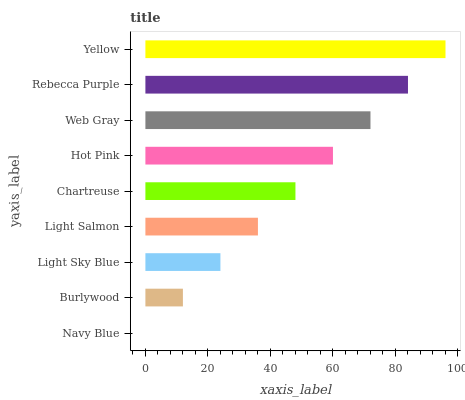Is Navy Blue the minimum?
Answer yes or no. Yes. Is Yellow the maximum?
Answer yes or no. Yes. Is Burlywood the minimum?
Answer yes or no. No. Is Burlywood the maximum?
Answer yes or no. No. Is Burlywood greater than Navy Blue?
Answer yes or no. Yes. Is Navy Blue less than Burlywood?
Answer yes or no. Yes. Is Navy Blue greater than Burlywood?
Answer yes or no. No. Is Burlywood less than Navy Blue?
Answer yes or no. No. Is Chartreuse the high median?
Answer yes or no. Yes. Is Chartreuse the low median?
Answer yes or no. Yes. Is Light Sky Blue the high median?
Answer yes or no. No. Is Yellow the low median?
Answer yes or no. No. 